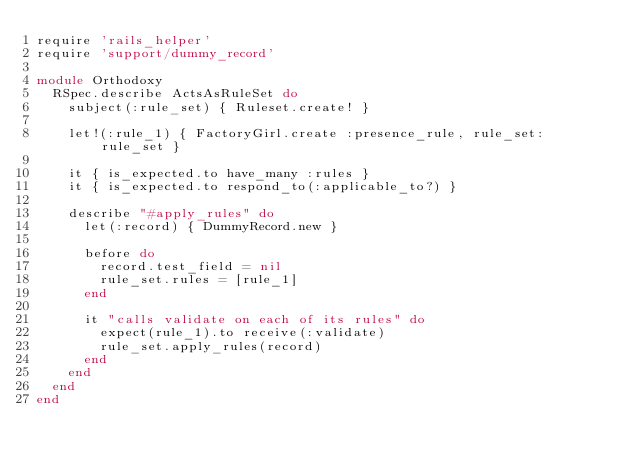<code> <loc_0><loc_0><loc_500><loc_500><_Ruby_>require 'rails_helper'
require 'support/dummy_record'

module Orthodoxy
  RSpec.describe ActsAsRuleSet do
    subject(:rule_set) { Ruleset.create! }

    let!(:rule_1) { FactoryGirl.create :presence_rule, rule_set: rule_set }

    it { is_expected.to have_many :rules }
    it { is_expected.to respond_to(:applicable_to?) }

    describe "#apply_rules" do
      let(:record) { DummyRecord.new }

      before do
        record.test_field = nil
        rule_set.rules = [rule_1]
      end

      it "calls validate on each of its rules" do
        expect(rule_1).to receive(:validate)
        rule_set.apply_rules(record)
      end
    end
  end
end
</code> 